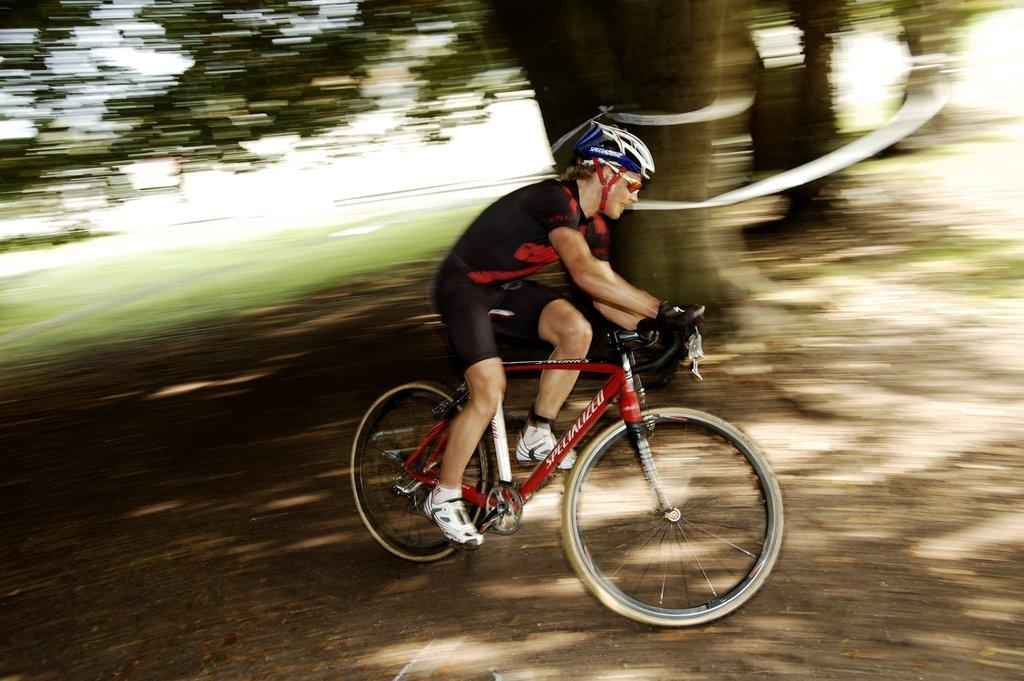What is the main subject of the image? There is a person cycling in the image. What can be seen behind the cyclist? There are trees behind the cyclist. What type of vegetation is visible in the background of the image? There is grass visible in the background of the image. How many chickens are following the cyclist in the image? There are no chickens present in the image. What shape is the governor in the image? There is no governor present in the image. 